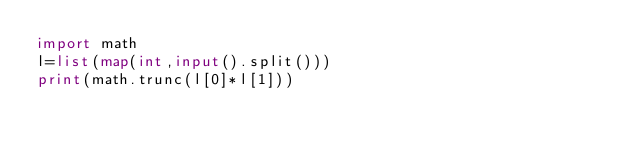Convert code to text. <code><loc_0><loc_0><loc_500><loc_500><_Python_>import math
l=list(map(int,input().split()))
print(math.trunc(l[0]*l[1]))</code> 